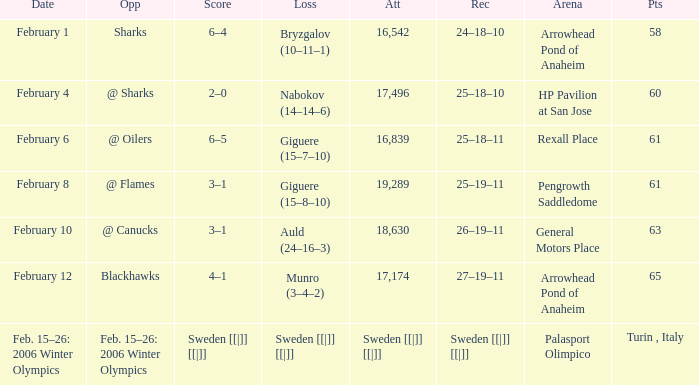What is the record at Arrowhead Pond of Anaheim, when the loss was Bryzgalov (10–11–1)? 24–18–10. 